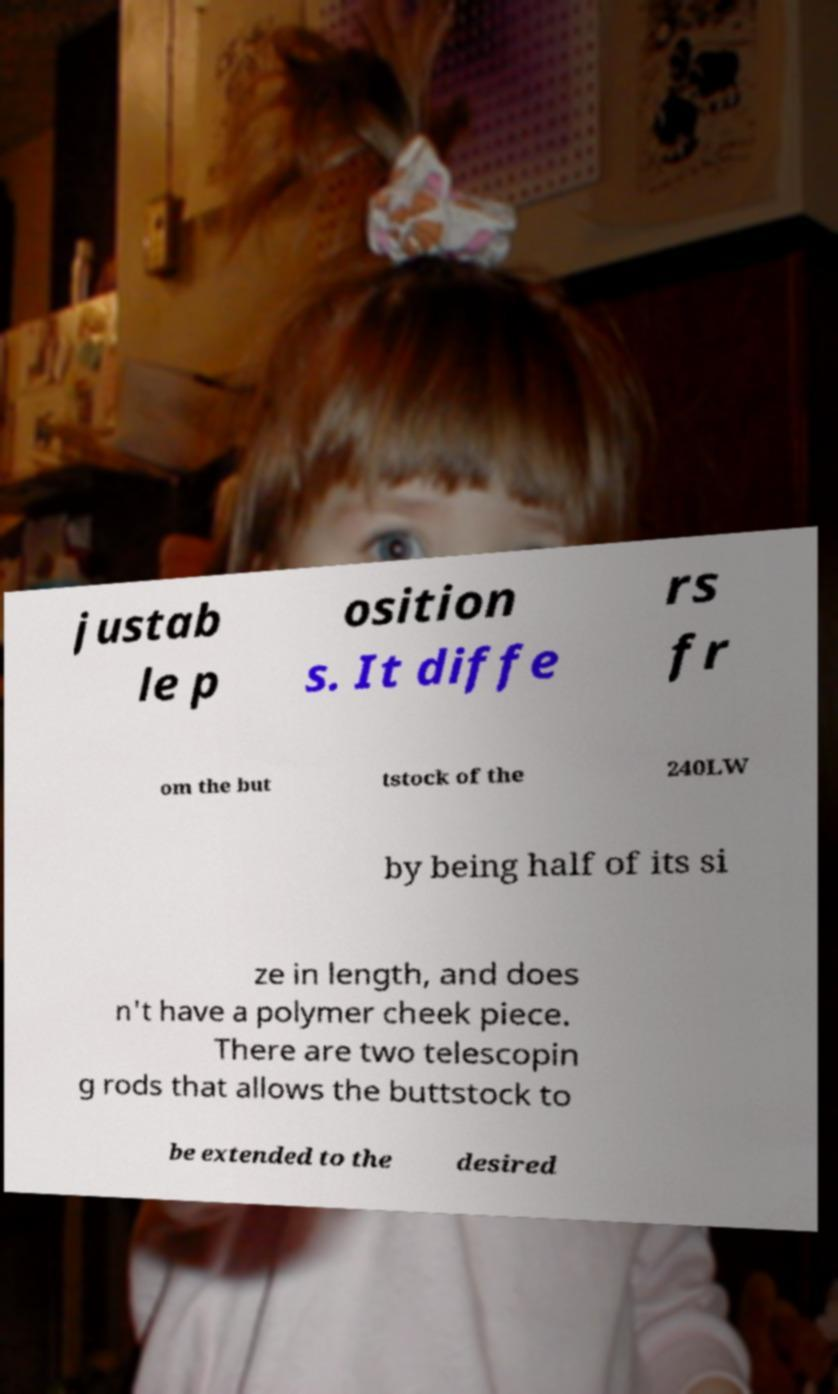Please read and relay the text visible in this image. What does it say? justab le p osition s. It diffe rs fr om the but tstock of the 240LW by being half of its si ze in length, and does n't have a polymer cheek piece. There are two telescopin g rods that allows the buttstock to be extended to the desired 